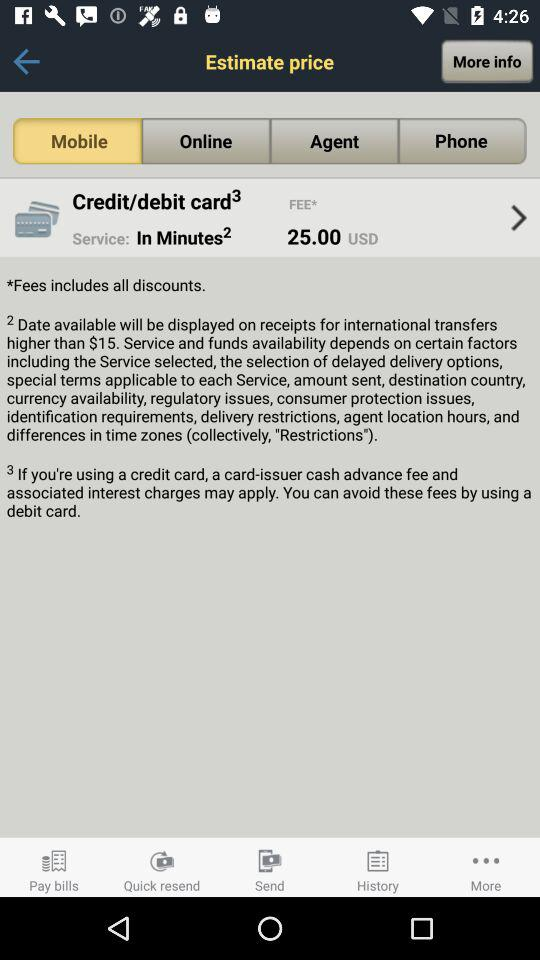Which option is selected? The selected option is "Mobile". 